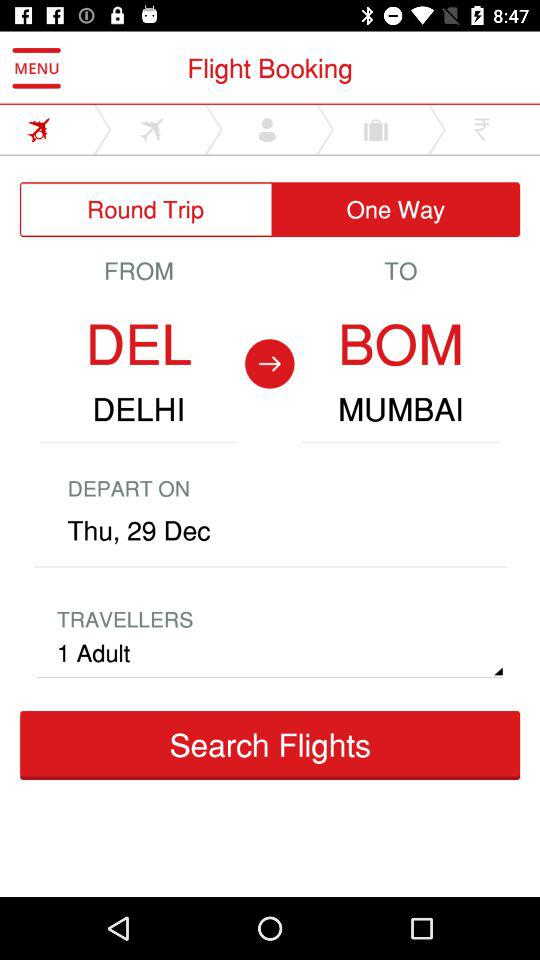From which city will the ticket be booked? The ticket will be booked from Delhi. 